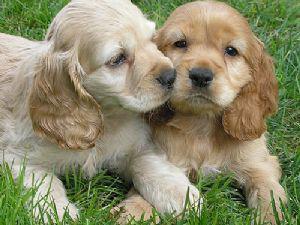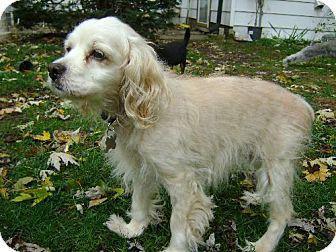The first image is the image on the left, the second image is the image on the right. Considering the images on both sides, is "There is a fence in the background of one of the images." valid? Answer yes or no. No. 